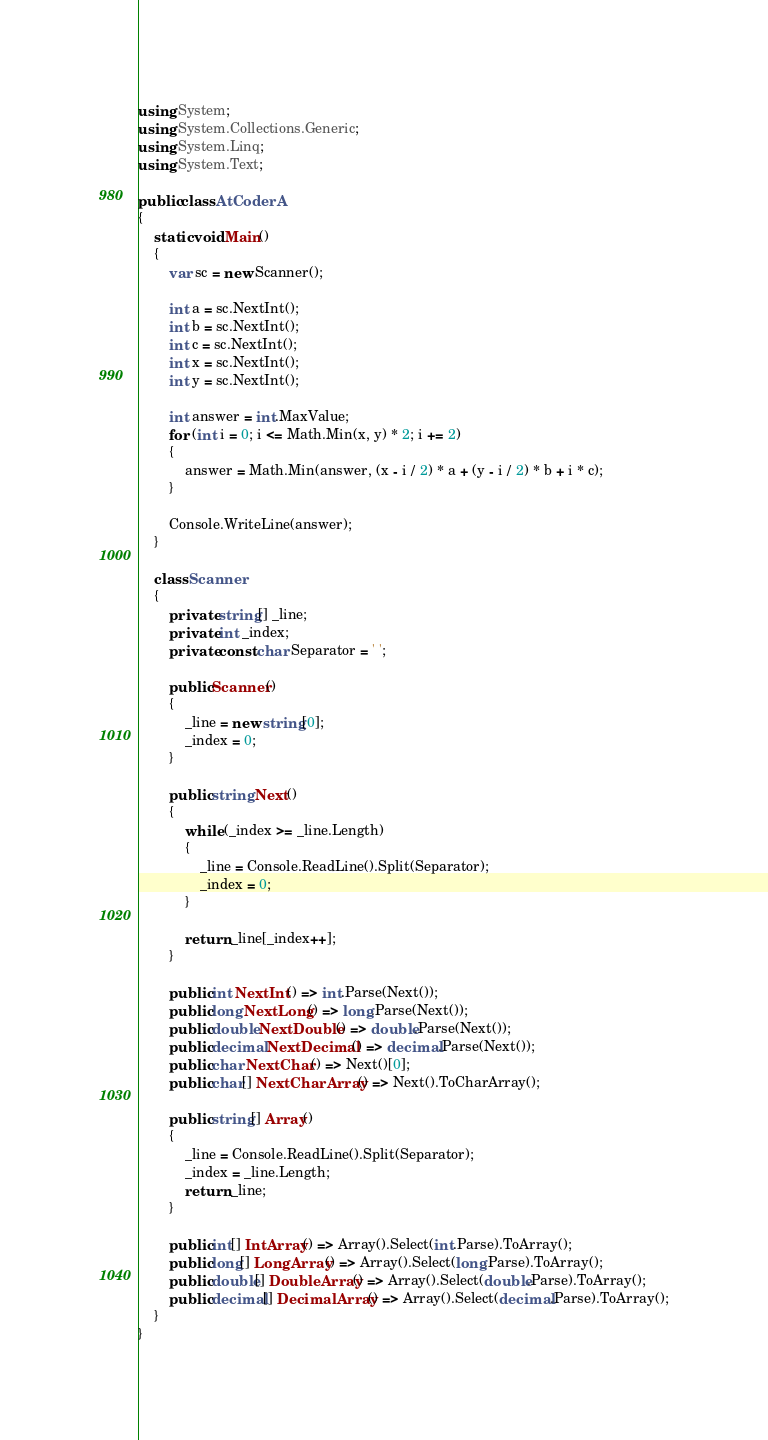Convert code to text. <code><loc_0><loc_0><loc_500><loc_500><_C#_>using System;
using System.Collections.Generic;
using System.Linq;
using System.Text;

public class AtCoderA
{
    static void Main()
    {
        var sc = new Scanner();

        int a = sc.NextInt();
        int b = sc.NextInt();
        int c = sc.NextInt();
        int x = sc.NextInt();
        int y = sc.NextInt();

        int answer = int.MaxValue;
        for (int i = 0; i <= Math.Min(x, y) * 2; i += 2)
        {
            answer = Math.Min(answer, (x - i / 2) * a + (y - i / 2) * b + i * c);
        }

        Console.WriteLine(answer);
    }

    class Scanner
    {
        private string[] _line;
        private int _index;
        private const char Separator = ' ';

        public Scanner()
        {
            _line = new string[0];
            _index = 0;
        }

        public string Next()
        {
            while (_index >= _line.Length)
            {
                _line = Console.ReadLine().Split(Separator);
                _index = 0;
            }

            return _line[_index++];
        }

        public int NextInt() => int.Parse(Next());
        public long NextLong() => long.Parse(Next());
        public double NextDouble() => double.Parse(Next());
        public decimal NextDecimal() => decimal.Parse(Next());
        public char NextChar() => Next()[0];
        public char[] NextCharArray() => Next().ToCharArray();

        public string[] Array()
        {
            _line = Console.ReadLine().Split(Separator);
            _index = _line.Length;
            return _line;
        }

        public int[] IntArray() => Array().Select(int.Parse).ToArray();
        public long[] LongArray() => Array().Select(long.Parse).ToArray();
        public double[] DoubleArray() => Array().Select(double.Parse).ToArray();
        public decimal[] DecimalArray() => Array().Select(decimal.Parse).ToArray();
    }
}</code> 